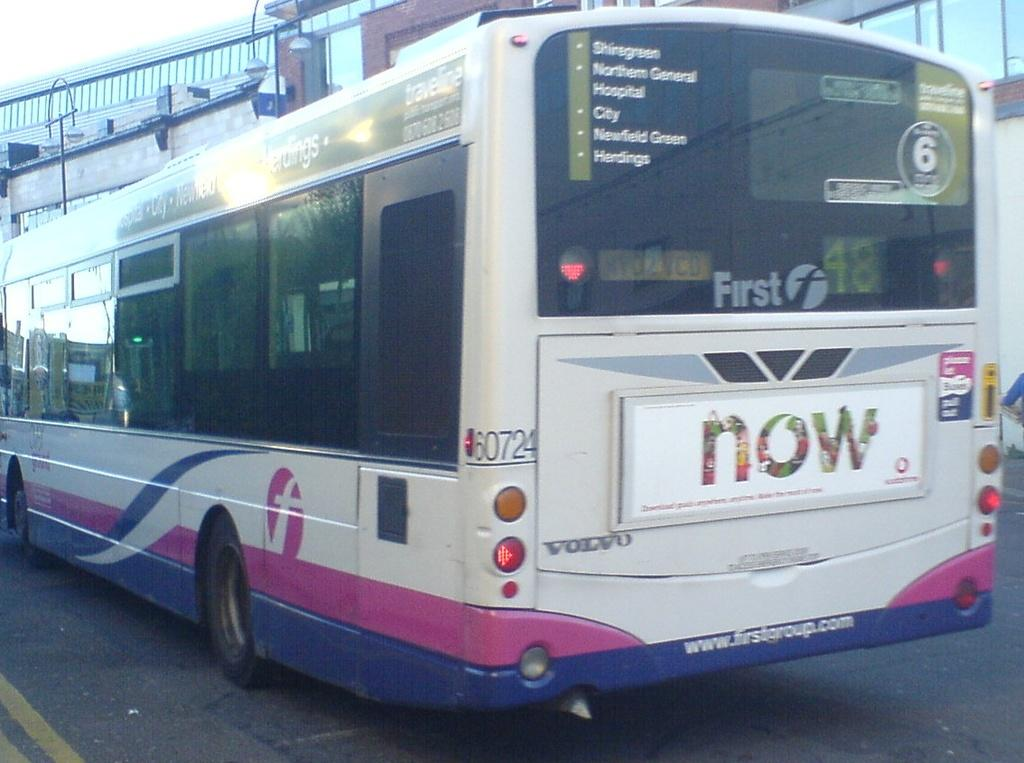What is the main subject of the image? The main subject of the image is a bus. Where is the bus located in the image? The bus is on the road in the image. What can be seen in the background of the image? There are buildings and light poles in the background of the image. What type of badge is the bus driver wearing in the image? There is no bus driver visible in the image, so it is not possible to determine if they are wearing a badge. 